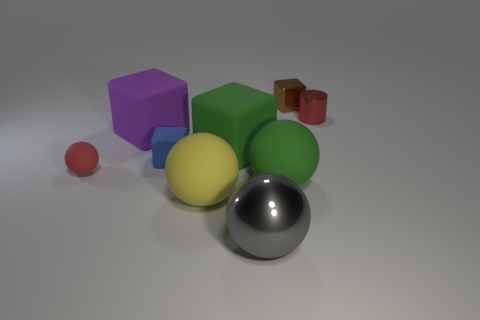Subtract all green matte blocks. How many blocks are left? 3 Subtract all green cubes. How many cubes are left? 3 Subtract 0 yellow cubes. How many objects are left? 9 Subtract all blocks. How many objects are left? 5 Subtract 4 blocks. How many blocks are left? 0 Subtract all blue blocks. Subtract all blue cylinders. How many blocks are left? 3 Subtract all brown cubes. How many red balls are left? 1 Subtract all tiny purple cylinders. Subtract all red rubber balls. How many objects are left? 8 Add 5 small brown shiny things. How many small brown shiny things are left? 6 Add 9 purple objects. How many purple objects exist? 10 